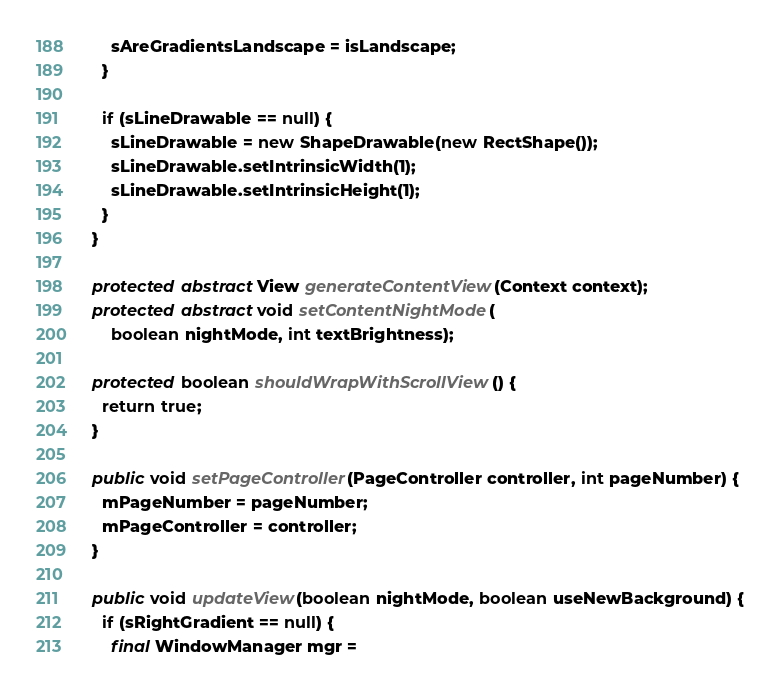<code> <loc_0><loc_0><loc_500><loc_500><_Java_>      sAreGradientsLandscape = isLandscape;
    }

    if (sLineDrawable == null) {
      sLineDrawable = new ShapeDrawable(new RectShape());
      sLineDrawable.setIntrinsicWidth(1);
      sLineDrawable.setIntrinsicHeight(1);
    }
  }

  protected abstract View generateContentView(Context context);
  protected abstract void setContentNightMode(
      boolean nightMode, int textBrightness);

  protected boolean shouldWrapWithScrollView() {
    return true;
  }

  public void setPageController(PageController controller, int pageNumber) {
    mPageNumber = pageNumber;
    mPageController = controller;
  }

  public void updateView(boolean nightMode, boolean useNewBackground) {
    if (sRightGradient == null) {
      final WindowManager mgr =</code> 